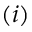<formula> <loc_0><loc_0><loc_500><loc_500>( i )</formula> 